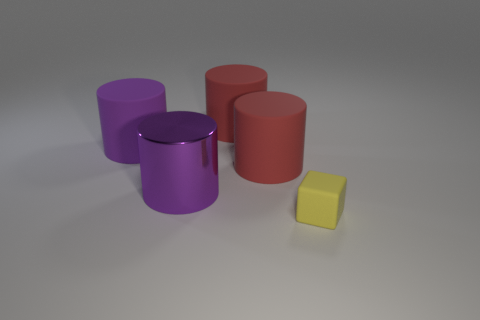What is the light source in this scene? The scene seems to be illuminated by a diffuse light source coming from above, as evidenced by the soft shadows directly underneath the objects and the soft gradation of light across the surfaces. 